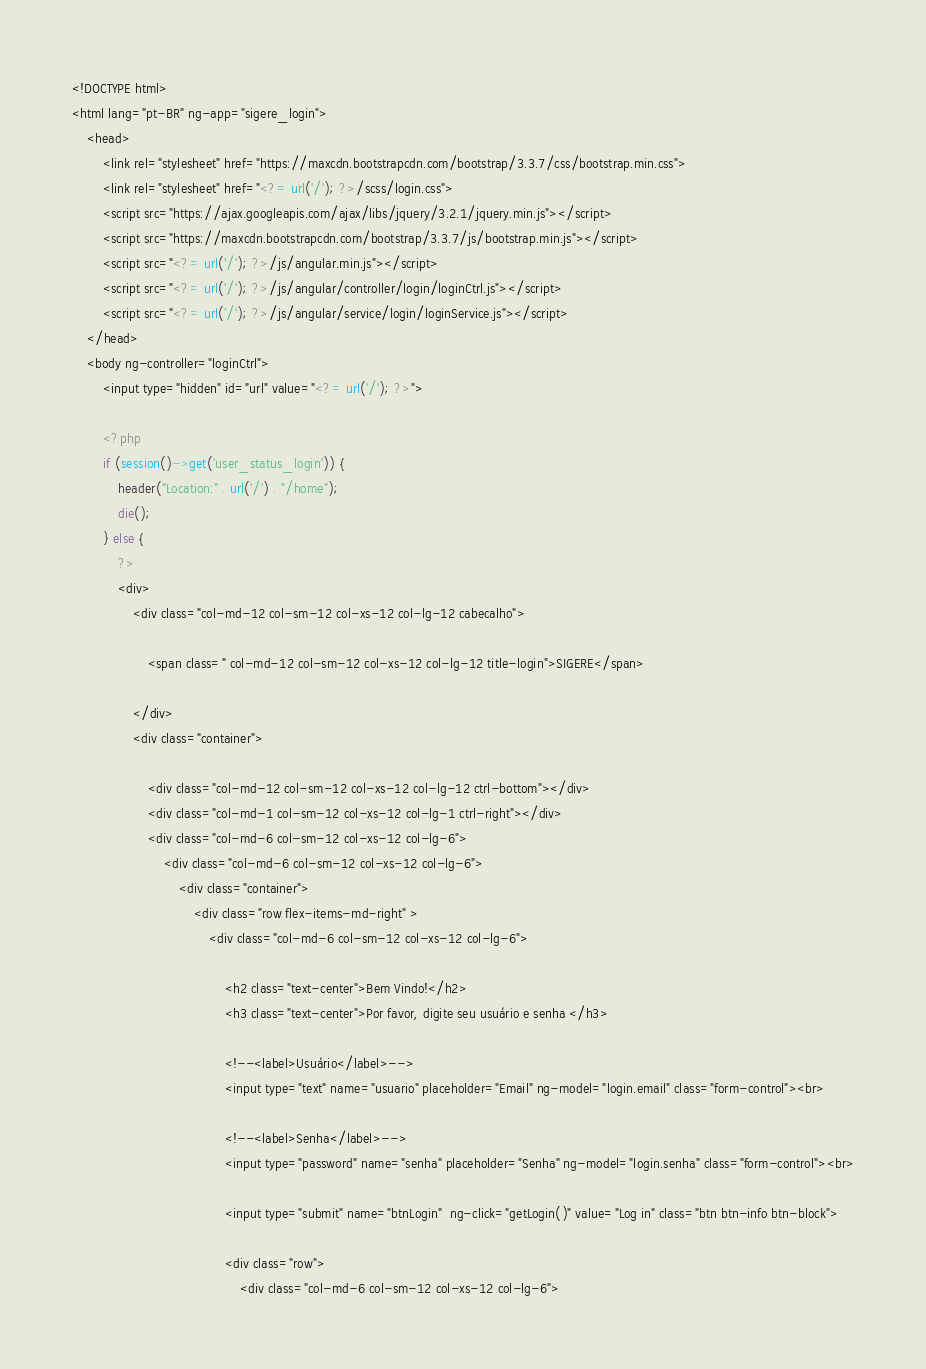Convert code to text. <code><loc_0><loc_0><loc_500><loc_500><_PHP_><!DOCTYPE html>
<html lang="pt-BR" ng-app="sigere_login">
    <head>
        <link rel="stylesheet" href="https://maxcdn.bootstrapcdn.com/bootstrap/3.3.7/css/bootstrap.min.css">
        <link rel="stylesheet" href="<?= url('/'); ?>/scss/login.css">
        <script src="https://ajax.googleapis.com/ajax/libs/jquery/3.2.1/jquery.min.js"></script>
        <script src="https://maxcdn.bootstrapcdn.com/bootstrap/3.3.7/js/bootstrap.min.js"></script>
        <script src="<?= url('/'); ?>/js/angular.min.js"></script>
        <script src="<?= url('/'); ?>/js/angular/controller/login/loginCtrl.js"></script>
        <script src="<?= url('/'); ?>/js/angular/service/login/loginService.js"></script>
    </head>
    <body ng-controller="loginCtrl">
        <input type="hidden" id="url" value="<?= url('/'); ?>">

        <?php
        if (session()->get('user_status_login')) {
            header("Location:" . url('/') . "/home");
            die();
        } else {
            ?>
            <div>
                <div class="col-md-12 col-sm-12 col-xs-12 col-lg-12 cabecalho">

                    <span class=" col-md-12 col-sm-12 col-xs-12 col-lg-12 title-login">SIGERE</span>

                </div>
                <div class="container">

                    <div class="col-md-12 col-sm-12 col-xs-12 col-lg-12 ctrl-bottom"></div>
                    <div class="col-md-1 col-sm-12 col-xs-12 col-lg-1 ctrl-right"></div>
                    <div class="col-md-6 col-sm-12 col-xs-12 col-lg-6">
                        <div class="col-md-6 col-sm-12 col-xs-12 col-lg-6">
                            <div class="container">
                                <div class="row flex-items-md-right" >
                                    <div class="col-md-6 col-sm-12 col-xs-12 col-lg-6">

                                        <h2 class="text-center">Bem Vindo!</h2>
                                        <h3 class="text-center">Por favor, digite seu usuário e senha </h3>

                                        <!--<label>Usuário</label>-->
                                        <input type="text" name="usuario" placeholder="Email" ng-model="login.email" class="form-control"><br>

                                        <!--<label>Senha</label>-->
                                        <input type="password" name="senha" placeholder="Senha" ng-model="login.senha" class="form-control"><br>

                                        <input type="submit" name="btnLogin"  ng-click="getLogin()" value="Log in" class="btn btn-info btn-block">

                                        <div class="row"> 
                                            <div class="col-md-6 col-sm-12 col-xs-12 col-lg-6"></code> 